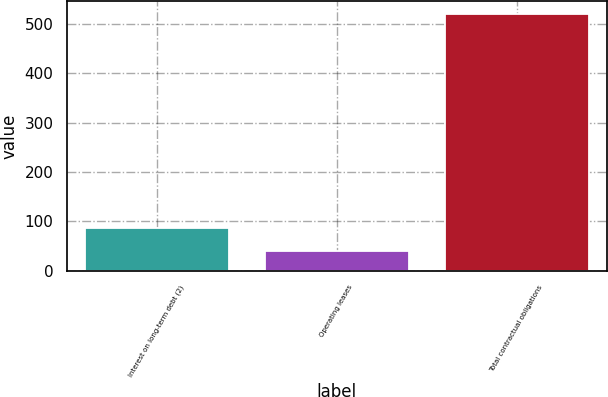<chart> <loc_0><loc_0><loc_500><loc_500><bar_chart><fcel>Interest on long-term debt (2)<fcel>Operating leases<fcel>Total contractual obligations<nl><fcel>87.3<fcel>39.2<fcel>520.2<nl></chart> 